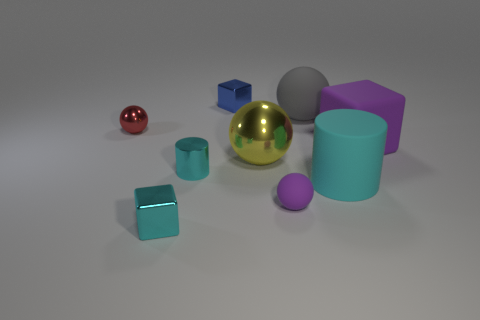Do the small rubber sphere and the cube that is right of the gray thing have the same color?
Provide a short and direct response. Yes. There is a big rubber object that is the same color as the small rubber sphere; what shape is it?
Offer a terse response. Cube. Do the metallic thing that is behind the red ball and the purple rubber thing that is to the right of the gray matte ball have the same shape?
Make the answer very short. Yes. Is the number of tiny purple things that are right of the large gray matte ball the same as the number of large green metallic objects?
Ensure brevity in your answer.  Yes. Are there any things that are on the right side of the purple object in front of the big yellow metallic ball?
Offer a terse response. Yes. Is there any other thing of the same color as the small shiny sphere?
Keep it short and to the point. No. Are the small cube behind the tiny purple ball and the big gray sphere made of the same material?
Your answer should be compact. No. Are there an equal number of red things on the left side of the gray object and metallic balls behind the big purple cube?
Ensure brevity in your answer.  Yes. What size is the thing to the right of the cyan cylinder that is to the right of the purple ball?
Offer a very short reply. Large. There is a tiny object that is both behind the large yellow shiny thing and in front of the tiny blue thing; what material is it?
Keep it short and to the point. Metal. 